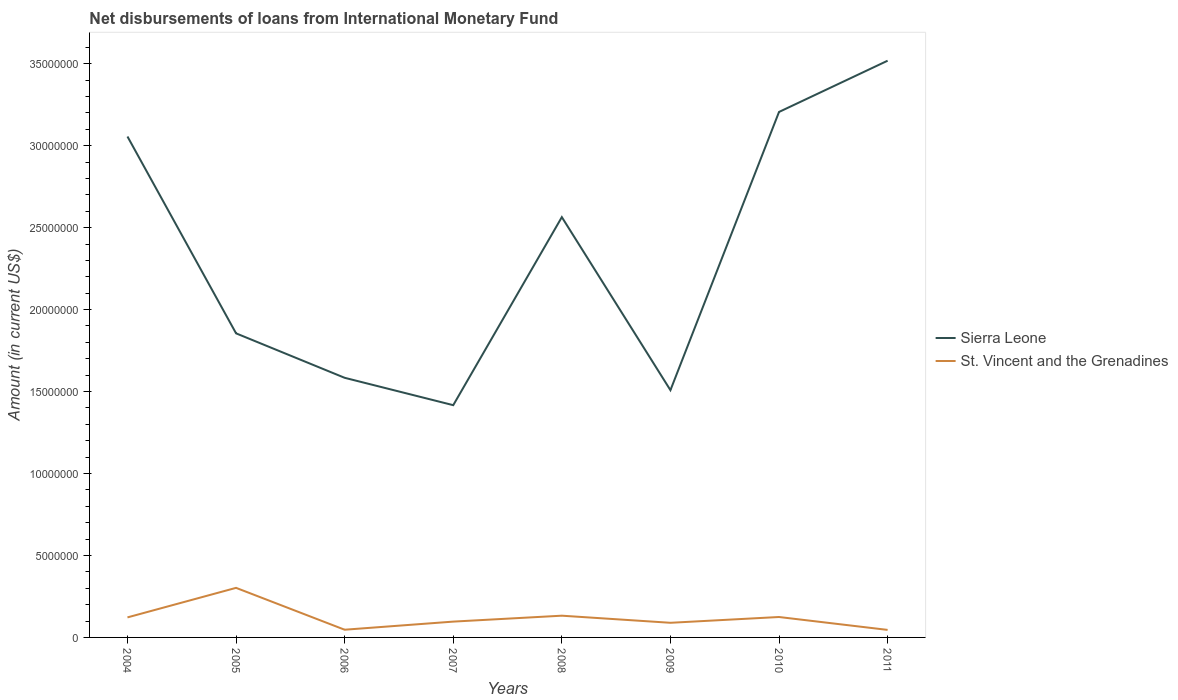Does the line corresponding to Sierra Leone intersect with the line corresponding to St. Vincent and the Grenadines?
Ensure brevity in your answer.  No. Across all years, what is the maximum amount of loans disbursed in Sierra Leone?
Your answer should be very brief. 1.42e+07. In which year was the amount of loans disbursed in St. Vincent and the Grenadines maximum?
Offer a terse response. 2011. What is the total amount of loans disbursed in Sierra Leone in the graph?
Keep it short and to the point. -2.10e+07. What is the difference between the highest and the second highest amount of loans disbursed in Sierra Leone?
Keep it short and to the point. 2.10e+07. What is the difference between the highest and the lowest amount of loans disbursed in Sierra Leone?
Provide a short and direct response. 4. Is the amount of loans disbursed in Sierra Leone strictly greater than the amount of loans disbursed in St. Vincent and the Grenadines over the years?
Keep it short and to the point. No. How many lines are there?
Keep it short and to the point. 2. How many years are there in the graph?
Your answer should be compact. 8. Does the graph contain grids?
Your answer should be very brief. No. Where does the legend appear in the graph?
Keep it short and to the point. Center right. How are the legend labels stacked?
Make the answer very short. Vertical. What is the title of the graph?
Provide a succinct answer. Net disbursements of loans from International Monetary Fund. Does "Greece" appear as one of the legend labels in the graph?
Your response must be concise. No. What is the Amount (in current US$) of Sierra Leone in 2004?
Give a very brief answer. 3.06e+07. What is the Amount (in current US$) of St. Vincent and the Grenadines in 2004?
Keep it short and to the point. 1.22e+06. What is the Amount (in current US$) of Sierra Leone in 2005?
Make the answer very short. 1.86e+07. What is the Amount (in current US$) in St. Vincent and the Grenadines in 2005?
Provide a short and direct response. 3.02e+06. What is the Amount (in current US$) in Sierra Leone in 2006?
Ensure brevity in your answer.  1.58e+07. What is the Amount (in current US$) in St. Vincent and the Grenadines in 2006?
Ensure brevity in your answer.  4.70e+05. What is the Amount (in current US$) of Sierra Leone in 2007?
Your answer should be very brief. 1.42e+07. What is the Amount (in current US$) in St. Vincent and the Grenadines in 2007?
Your answer should be very brief. 9.65e+05. What is the Amount (in current US$) of Sierra Leone in 2008?
Give a very brief answer. 2.56e+07. What is the Amount (in current US$) of St. Vincent and the Grenadines in 2008?
Your response must be concise. 1.33e+06. What is the Amount (in current US$) in Sierra Leone in 2009?
Keep it short and to the point. 1.51e+07. What is the Amount (in current US$) in St. Vincent and the Grenadines in 2009?
Your response must be concise. 8.93e+05. What is the Amount (in current US$) of Sierra Leone in 2010?
Your response must be concise. 3.21e+07. What is the Amount (in current US$) of St. Vincent and the Grenadines in 2010?
Give a very brief answer. 1.25e+06. What is the Amount (in current US$) in Sierra Leone in 2011?
Your answer should be very brief. 3.52e+07. What is the Amount (in current US$) of St. Vincent and the Grenadines in 2011?
Give a very brief answer. 4.59e+05. Across all years, what is the maximum Amount (in current US$) in Sierra Leone?
Provide a succinct answer. 3.52e+07. Across all years, what is the maximum Amount (in current US$) of St. Vincent and the Grenadines?
Keep it short and to the point. 3.02e+06. Across all years, what is the minimum Amount (in current US$) of Sierra Leone?
Give a very brief answer. 1.42e+07. Across all years, what is the minimum Amount (in current US$) of St. Vincent and the Grenadines?
Offer a terse response. 4.59e+05. What is the total Amount (in current US$) in Sierra Leone in the graph?
Make the answer very short. 1.87e+08. What is the total Amount (in current US$) in St. Vincent and the Grenadines in the graph?
Your answer should be compact. 9.60e+06. What is the difference between the Amount (in current US$) in Sierra Leone in 2004 and that in 2005?
Offer a terse response. 1.20e+07. What is the difference between the Amount (in current US$) of St. Vincent and the Grenadines in 2004 and that in 2005?
Provide a short and direct response. -1.80e+06. What is the difference between the Amount (in current US$) of Sierra Leone in 2004 and that in 2006?
Your answer should be compact. 1.47e+07. What is the difference between the Amount (in current US$) in St. Vincent and the Grenadines in 2004 and that in 2006?
Ensure brevity in your answer.  7.52e+05. What is the difference between the Amount (in current US$) of Sierra Leone in 2004 and that in 2007?
Keep it short and to the point. 1.64e+07. What is the difference between the Amount (in current US$) of St. Vincent and the Grenadines in 2004 and that in 2007?
Make the answer very short. 2.57e+05. What is the difference between the Amount (in current US$) of Sierra Leone in 2004 and that in 2008?
Your response must be concise. 4.92e+06. What is the difference between the Amount (in current US$) of St. Vincent and the Grenadines in 2004 and that in 2008?
Your answer should be very brief. -1.04e+05. What is the difference between the Amount (in current US$) of Sierra Leone in 2004 and that in 2009?
Keep it short and to the point. 1.55e+07. What is the difference between the Amount (in current US$) in St. Vincent and the Grenadines in 2004 and that in 2009?
Make the answer very short. 3.29e+05. What is the difference between the Amount (in current US$) in Sierra Leone in 2004 and that in 2010?
Offer a very short reply. -1.50e+06. What is the difference between the Amount (in current US$) in St. Vincent and the Grenadines in 2004 and that in 2010?
Make the answer very short. -2.40e+04. What is the difference between the Amount (in current US$) of Sierra Leone in 2004 and that in 2011?
Keep it short and to the point. -4.62e+06. What is the difference between the Amount (in current US$) of St. Vincent and the Grenadines in 2004 and that in 2011?
Provide a succinct answer. 7.63e+05. What is the difference between the Amount (in current US$) in Sierra Leone in 2005 and that in 2006?
Ensure brevity in your answer.  2.71e+06. What is the difference between the Amount (in current US$) of St. Vincent and the Grenadines in 2005 and that in 2006?
Provide a short and direct response. 2.55e+06. What is the difference between the Amount (in current US$) in Sierra Leone in 2005 and that in 2007?
Offer a very short reply. 4.38e+06. What is the difference between the Amount (in current US$) of St. Vincent and the Grenadines in 2005 and that in 2007?
Make the answer very short. 2.06e+06. What is the difference between the Amount (in current US$) in Sierra Leone in 2005 and that in 2008?
Keep it short and to the point. -7.09e+06. What is the difference between the Amount (in current US$) in St. Vincent and the Grenadines in 2005 and that in 2008?
Your answer should be very brief. 1.70e+06. What is the difference between the Amount (in current US$) in Sierra Leone in 2005 and that in 2009?
Give a very brief answer. 3.47e+06. What is the difference between the Amount (in current US$) of St. Vincent and the Grenadines in 2005 and that in 2009?
Provide a succinct answer. 2.13e+06. What is the difference between the Amount (in current US$) in Sierra Leone in 2005 and that in 2010?
Give a very brief answer. -1.35e+07. What is the difference between the Amount (in current US$) of St. Vincent and the Grenadines in 2005 and that in 2010?
Ensure brevity in your answer.  1.78e+06. What is the difference between the Amount (in current US$) of Sierra Leone in 2005 and that in 2011?
Give a very brief answer. -1.66e+07. What is the difference between the Amount (in current US$) of St. Vincent and the Grenadines in 2005 and that in 2011?
Your response must be concise. 2.56e+06. What is the difference between the Amount (in current US$) of Sierra Leone in 2006 and that in 2007?
Provide a short and direct response. 1.67e+06. What is the difference between the Amount (in current US$) in St. Vincent and the Grenadines in 2006 and that in 2007?
Make the answer very short. -4.95e+05. What is the difference between the Amount (in current US$) in Sierra Leone in 2006 and that in 2008?
Your answer should be compact. -9.80e+06. What is the difference between the Amount (in current US$) in St. Vincent and the Grenadines in 2006 and that in 2008?
Ensure brevity in your answer.  -8.56e+05. What is the difference between the Amount (in current US$) in Sierra Leone in 2006 and that in 2009?
Your answer should be compact. 7.55e+05. What is the difference between the Amount (in current US$) in St. Vincent and the Grenadines in 2006 and that in 2009?
Your answer should be compact. -4.23e+05. What is the difference between the Amount (in current US$) in Sierra Leone in 2006 and that in 2010?
Offer a very short reply. -1.62e+07. What is the difference between the Amount (in current US$) in St. Vincent and the Grenadines in 2006 and that in 2010?
Your answer should be compact. -7.76e+05. What is the difference between the Amount (in current US$) in Sierra Leone in 2006 and that in 2011?
Offer a very short reply. -1.93e+07. What is the difference between the Amount (in current US$) of St. Vincent and the Grenadines in 2006 and that in 2011?
Provide a succinct answer. 1.10e+04. What is the difference between the Amount (in current US$) of Sierra Leone in 2007 and that in 2008?
Your answer should be very brief. -1.15e+07. What is the difference between the Amount (in current US$) of St. Vincent and the Grenadines in 2007 and that in 2008?
Provide a succinct answer. -3.61e+05. What is the difference between the Amount (in current US$) of Sierra Leone in 2007 and that in 2009?
Offer a very short reply. -9.15e+05. What is the difference between the Amount (in current US$) of St. Vincent and the Grenadines in 2007 and that in 2009?
Your response must be concise. 7.20e+04. What is the difference between the Amount (in current US$) of Sierra Leone in 2007 and that in 2010?
Make the answer very short. -1.79e+07. What is the difference between the Amount (in current US$) in St. Vincent and the Grenadines in 2007 and that in 2010?
Keep it short and to the point. -2.81e+05. What is the difference between the Amount (in current US$) of Sierra Leone in 2007 and that in 2011?
Ensure brevity in your answer.  -2.10e+07. What is the difference between the Amount (in current US$) in St. Vincent and the Grenadines in 2007 and that in 2011?
Offer a terse response. 5.06e+05. What is the difference between the Amount (in current US$) in Sierra Leone in 2008 and that in 2009?
Your answer should be very brief. 1.06e+07. What is the difference between the Amount (in current US$) of St. Vincent and the Grenadines in 2008 and that in 2009?
Your answer should be compact. 4.33e+05. What is the difference between the Amount (in current US$) in Sierra Leone in 2008 and that in 2010?
Offer a terse response. -6.42e+06. What is the difference between the Amount (in current US$) in St. Vincent and the Grenadines in 2008 and that in 2010?
Your response must be concise. 8.00e+04. What is the difference between the Amount (in current US$) of Sierra Leone in 2008 and that in 2011?
Keep it short and to the point. -9.54e+06. What is the difference between the Amount (in current US$) of St. Vincent and the Grenadines in 2008 and that in 2011?
Your answer should be compact. 8.67e+05. What is the difference between the Amount (in current US$) in Sierra Leone in 2009 and that in 2010?
Offer a very short reply. -1.70e+07. What is the difference between the Amount (in current US$) in St. Vincent and the Grenadines in 2009 and that in 2010?
Keep it short and to the point. -3.53e+05. What is the difference between the Amount (in current US$) of Sierra Leone in 2009 and that in 2011?
Your answer should be very brief. -2.01e+07. What is the difference between the Amount (in current US$) in St. Vincent and the Grenadines in 2009 and that in 2011?
Ensure brevity in your answer.  4.34e+05. What is the difference between the Amount (in current US$) in Sierra Leone in 2010 and that in 2011?
Give a very brief answer. -3.13e+06. What is the difference between the Amount (in current US$) in St. Vincent and the Grenadines in 2010 and that in 2011?
Keep it short and to the point. 7.87e+05. What is the difference between the Amount (in current US$) of Sierra Leone in 2004 and the Amount (in current US$) of St. Vincent and the Grenadines in 2005?
Provide a short and direct response. 2.75e+07. What is the difference between the Amount (in current US$) of Sierra Leone in 2004 and the Amount (in current US$) of St. Vincent and the Grenadines in 2006?
Your answer should be compact. 3.01e+07. What is the difference between the Amount (in current US$) of Sierra Leone in 2004 and the Amount (in current US$) of St. Vincent and the Grenadines in 2007?
Make the answer very short. 2.96e+07. What is the difference between the Amount (in current US$) in Sierra Leone in 2004 and the Amount (in current US$) in St. Vincent and the Grenadines in 2008?
Offer a very short reply. 2.92e+07. What is the difference between the Amount (in current US$) of Sierra Leone in 2004 and the Amount (in current US$) of St. Vincent and the Grenadines in 2009?
Your answer should be compact. 2.97e+07. What is the difference between the Amount (in current US$) of Sierra Leone in 2004 and the Amount (in current US$) of St. Vincent and the Grenadines in 2010?
Provide a short and direct response. 2.93e+07. What is the difference between the Amount (in current US$) of Sierra Leone in 2004 and the Amount (in current US$) of St. Vincent and the Grenadines in 2011?
Offer a terse response. 3.01e+07. What is the difference between the Amount (in current US$) in Sierra Leone in 2005 and the Amount (in current US$) in St. Vincent and the Grenadines in 2006?
Your answer should be very brief. 1.81e+07. What is the difference between the Amount (in current US$) in Sierra Leone in 2005 and the Amount (in current US$) in St. Vincent and the Grenadines in 2007?
Offer a terse response. 1.76e+07. What is the difference between the Amount (in current US$) of Sierra Leone in 2005 and the Amount (in current US$) of St. Vincent and the Grenadines in 2008?
Make the answer very short. 1.72e+07. What is the difference between the Amount (in current US$) of Sierra Leone in 2005 and the Amount (in current US$) of St. Vincent and the Grenadines in 2009?
Offer a terse response. 1.77e+07. What is the difference between the Amount (in current US$) in Sierra Leone in 2005 and the Amount (in current US$) in St. Vincent and the Grenadines in 2010?
Make the answer very short. 1.73e+07. What is the difference between the Amount (in current US$) in Sierra Leone in 2005 and the Amount (in current US$) in St. Vincent and the Grenadines in 2011?
Ensure brevity in your answer.  1.81e+07. What is the difference between the Amount (in current US$) in Sierra Leone in 2006 and the Amount (in current US$) in St. Vincent and the Grenadines in 2007?
Your response must be concise. 1.49e+07. What is the difference between the Amount (in current US$) in Sierra Leone in 2006 and the Amount (in current US$) in St. Vincent and the Grenadines in 2008?
Your answer should be very brief. 1.45e+07. What is the difference between the Amount (in current US$) of Sierra Leone in 2006 and the Amount (in current US$) of St. Vincent and the Grenadines in 2009?
Your answer should be compact. 1.49e+07. What is the difference between the Amount (in current US$) of Sierra Leone in 2006 and the Amount (in current US$) of St. Vincent and the Grenadines in 2010?
Make the answer very short. 1.46e+07. What is the difference between the Amount (in current US$) of Sierra Leone in 2006 and the Amount (in current US$) of St. Vincent and the Grenadines in 2011?
Your answer should be very brief. 1.54e+07. What is the difference between the Amount (in current US$) of Sierra Leone in 2007 and the Amount (in current US$) of St. Vincent and the Grenadines in 2008?
Offer a terse response. 1.28e+07. What is the difference between the Amount (in current US$) in Sierra Leone in 2007 and the Amount (in current US$) in St. Vincent and the Grenadines in 2009?
Keep it short and to the point. 1.33e+07. What is the difference between the Amount (in current US$) in Sierra Leone in 2007 and the Amount (in current US$) in St. Vincent and the Grenadines in 2010?
Give a very brief answer. 1.29e+07. What is the difference between the Amount (in current US$) of Sierra Leone in 2007 and the Amount (in current US$) of St. Vincent and the Grenadines in 2011?
Keep it short and to the point. 1.37e+07. What is the difference between the Amount (in current US$) of Sierra Leone in 2008 and the Amount (in current US$) of St. Vincent and the Grenadines in 2009?
Your answer should be compact. 2.47e+07. What is the difference between the Amount (in current US$) of Sierra Leone in 2008 and the Amount (in current US$) of St. Vincent and the Grenadines in 2010?
Offer a very short reply. 2.44e+07. What is the difference between the Amount (in current US$) in Sierra Leone in 2008 and the Amount (in current US$) in St. Vincent and the Grenadines in 2011?
Provide a succinct answer. 2.52e+07. What is the difference between the Amount (in current US$) in Sierra Leone in 2009 and the Amount (in current US$) in St. Vincent and the Grenadines in 2010?
Provide a succinct answer. 1.38e+07. What is the difference between the Amount (in current US$) of Sierra Leone in 2009 and the Amount (in current US$) of St. Vincent and the Grenadines in 2011?
Offer a terse response. 1.46e+07. What is the difference between the Amount (in current US$) of Sierra Leone in 2010 and the Amount (in current US$) of St. Vincent and the Grenadines in 2011?
Ensure brevity in your answer.  3.16e+07. What is the average Amount (in current US$) of Sierra Leone per year?
Your answer should be very brief. 2.34e+07. What is the average Amount (in current US$) in St. Vincent and the Grenadines per year?
Provide a succinct answer. 1.20e+06. In the year 2004, what is the difference between the Amount (in current US$) of Sierra Leone and Amount (in current US$) of St. Vincent and the Grenadines?
Your answer should be compact. 2.93e+07. In the year 2005, what is the difference between the Amount (in current US$) in Sierra Leone and Amount (in current US$) in St. Vincent and the Grenadines?
Make the answer very short. 1.55e+07. In the year 2006, what is the difference between the Amount (in current US$) in Sierra Leone and Amount (in current US$) in St. Vincent and the Grenadines?
Offer a terse response. 1.54e+07. In the year 2007, what is the difference between the Amount (in current US$) of Sierra Leone and Amount (in current US$) of St. Vincent and the Grenadines?
Offer a very short reply. 1.32e+07. In the year 2008, what is the difference between the Amount (in current US$) of Sierra Leone and Amount (in current US$) of St. Vincent and the Grenadines?
Keep it short and to the point. 2.43e+07. In the year 2009, what is the difference between the Amount (in current US$) in Sierra Leone and Amount (in current US$) in St. Vincent and the Grenadines?
Provide a succinct answer. 1.42e+07. In the year 2010, what is the difference between the Amount (in current US$) in Sierra Leone and Amount (in current US$) in St. Vincent and the Grenadines?
Provide a short and direct response. 3.08e+07. In the year 2011, what is the difference between the Amount (in current US$) in Sierra Leone and Amount (in current US$) in St. Vincent and the Grenadines?
Your response must be concise. 3.47e+07. What is the ratio of the Amount (in current US$) in Sierra Leone in 2004 to that in 2005?
Provide a short and direct response. 1.65. What is the ratio of the Amount (in current US$) of St. Vincent and the Grenadines in 2004 to that in 2005?
Offer a very short reply. 0.4. What is the ratio of the Amount (in current US$) of Sierra Leone in 2004 to that in 2006?
Keep it short and to the point. 1.93. What is the ratio of the Amount (in current US$) in Sierra Leone in 2004 to that in 2007?
Your answer should be compact. 2.16. What is the ratio of the Amount (in current US$) in St. Vincent and the Grenadines in 2004 to that in 2007?
Offer a terse response. 1.27. What is the ratio of the Amount (in current US$) in Sierra Leone in 2004 to that in 2008?
Offer a very short reply. 1.19. What is the ratio of the Amount (in current US$) in St. Vincent and the Grenadines in 2004 to that in 2008?
Make the answer very short. 0.92. What is the ratio of the Amount (in current US$) in Sierra Leone in 2004 to that in 2009?
Provide a short and direct response. 2.03. What is the ratio of the Amount (in current US$) of St. Vincent and the Grenadines in 2004 to that in 2009?
Provide a short and direct response. 1.37. What is the ratio of the Amount (in current US$) in Sierra Leone in 2004 to that in 2010?
Make the answer very short. 0.95. What is the ratio of the Amount (in current US$) in St. Vincent and the Grenadines in 2004 to that in 2010?
Your answer should be very brief. 0.98. What is the ratio of the Amount (in current US$) in Sierra Leone in 2004 to that in 2011?
Make the answer very short. 0.87. What is the ratio of the Amount (in current US$) in St. Vincent and the Grenadines in 2004 to that in 2011?
Provide a short and direct response. 2.66. What is the ratio of the Amount (in current US$) in Sierra Leone in 2005 to that in 2006?
Keep it short and to the point. 1.17. What is the ratio of the Amount (in current US$) of St. Vincent and the Grenadines in 2005 to that in 2006?
Offer a terse response. 6.43. What is the ratio of the Amount (in current US$) in Sierra Leone in 2005 to that in 2007?
Provide a short and direct response. 1.31. What is the ratio of the Amount (in current US$) of St. Vincent and the Grenadines in 2005 to that in 2007?
Your answer should be very brief. 3.13. What is the ratio of the Amount (in current US$) in Sierra Leone in 2005 to that in 2008?
Keep it short and to the point. 0.72. What is the ratio of the Amount (in current US$) in St. Vincent and the Grenadines in 2005 to that in 2008?
Provide a short and direct response. 2.28. What is the ratio of the Amount (in current US$) of Sierra Leone in 2005 to that in 2009?
Provide a short and direct response. 1.23. What is the ratio of the Amount (in current US$) in St. Vincent and the Grenadines in 2005 to that in 2009?
Your response must be concise. 3.39. What is the ratio of the Amount (in current US$) in Sierra Leone in 2005 to that in 2010?
Your answer should be very brief. 0.58. What is the ratio of the Amount (in current US$) in St. Vincent and the Grenadines in 2005 to that in 2010?
Make the answer very short. 2.43. What is the ratio of the Amount (in current US$) of Sierra Leone in 2005 to that in 2011?
Offer a terse response. 0.53. What is the ratio of the Amount (in current US$) of St. Vincent and the Grenadines in 2005 to that in 2011?
Make the answer very short. 6.59. What is the ratio of the Amount (in current US$) in Sierra Leone in 2006 to that in 2007?
Ensure brevity in your answer.  1.12. What is the ratio of the Amount (in current US$) of St. Vincent and the Grenadines in 2006 to that in 2007?
Give a very brief answer. 0.49. What is the ratio of the Amount (in current US$) in Sierra Leone in 2006 to that in 2008?
Keep it short and to the point. 0.62. What is the ratio of the Amount (in current US$) in St. Vincent and the Grenadines in 2006 to that in 2008?
Keep it short and to the point. 0.35. What is the ratio of the Amount (in current US$) in St. Vincent and the Grenadines in 2006 to that in 2009?
Your answer should be very brief. 0.53. What is the ratio of the Amount (in current US$) in Sierra Leone in 2006 to that in 2010?
Your answer should be very brief. 0.49. What is the ratio of the Amount (in current US$) in St. Vincent and the Grenadines in 2006 to that in 2010?
Ensure brevity in your answer.  0.38. What is the ratio of the Amount (in current US$) in Sierra Leone in 2006 to that in 2011?
Offer a terse response. 0.45. What is the ratio of the Amount (in current US$) in St. Vincent and the Grenadines in 2006 to that in 2011?
Ensure brevity in your answer.  1.02. What is the ratio of the Amount (in current US$) in Sierra Leone in 2007 to that in 2008?
Keep it short and to the point. 0.55. What is the ratio of the Amount (in current US$) of St. Vincent and the Grenadines in 2007 to that in 2008?
Offer a very short reply. 0.73. What is the ratio of the Amount (in current US$) of Sierra Leone in 2007 to that in 2009?
Offer a terse response. 0.94. What is the ratio of the Amount (in current US$) in St. Vincent and the Grenadines in 2007 to that in 2009?
Keep it short and to the point. 1.08. What is the ratio of the Amount (in current US$) of Sierra Leone in 2007 to that in 2010?
Offer a very short reply. 0.44. What is the ratio of the Amount (in current US$) in St. Vincent and the Grenadines in 2007 to that in 2010?
Make the answer very short. 0.77. What is the ratio of the Amount (in current US$) in Sierra Leone in 2007 to that in 2011?
Ensure brevity in your answer.  0.4. What is the ratio of the Amount (in current US$) of St. Vincent and the Grenadines in 2007 to that in 2011?
Give a very brief answer. 2.1. What is the ratio of the Amount (in current US$) of Sierra Leone in 2008 to that in 2009?
Your response must be concise. 1.7. What is the ratio of the Amount (in current US$) of St. Vincent and the Grenadines in 2008 to that in 2009?
Offer a terse response. 1.48. What is the ratio of the Amount (in current US$) of Sierra Leone in 2008 to that in 2010?
Keep it short and to the point. 0.8. What is the ratio of the Amount (in current US$) in St. Vincent and the Grenadines in 2008 to that in 2010?
Offer a terse response. 1.06. What is the ratio of the Amount (in current US$) of Sierra Leone in 2008 to that in 2011?
Your answer should be compact. 0.73. What is the ratio of the Amount (in current US$) in St. Vincent and the Grenadines in 2008 to that in 2011?
Give a very brief answer. 2.89. What is the ratio of the Amount (in current US$) in Sierra Leone in 2009 to that in 2010?
Offer a very short reply. 0.47. What is the ratio of the Amount (in current US$) of St. Vincent and the Grenadines in 2009 to that in 2010?
Your answer should be compact. 0.72. What is the ratio of the Amount (in current US$) of Sierra Leone in 2009 to that in 2011?
Provide a short and direct response. 0.43. What is the ratio of the Amount (in current US$) of St. Vincent and the Grenadines in 2009 to that in 2011?
Provide a succinct answer. 1.95. What is the ratio of the Amount (in current US$) of Sierra Leone in 2010 to that in 2011?
Ensure brevity in your answer.  0.91. What is the ratio of the Amount (in current US$) in St. Vincent and the Grenadines in 2010 to that in 2011?
Keep it short and to the point. 2.71. What is the difference between the highest and the second highest Amount (in current US$) in Sierra Leone?
Keep it short and to the point. 3.13e+06. What is the difference between the highest and the second highest Amount (in current US$) in St. Vincent and the Grenadines?
Provide a succinct answer. 1.70e+06. What is the difference between the highest and the lowest Amount (in current US$) of Sierra Leone?
Keep it short and to the point. 2.10e+07. What is the difference between the highest and the lowest Amount (in current US$) of St. Vincent and the Grenadines?
Offer a terse response. 2.56e+06. 